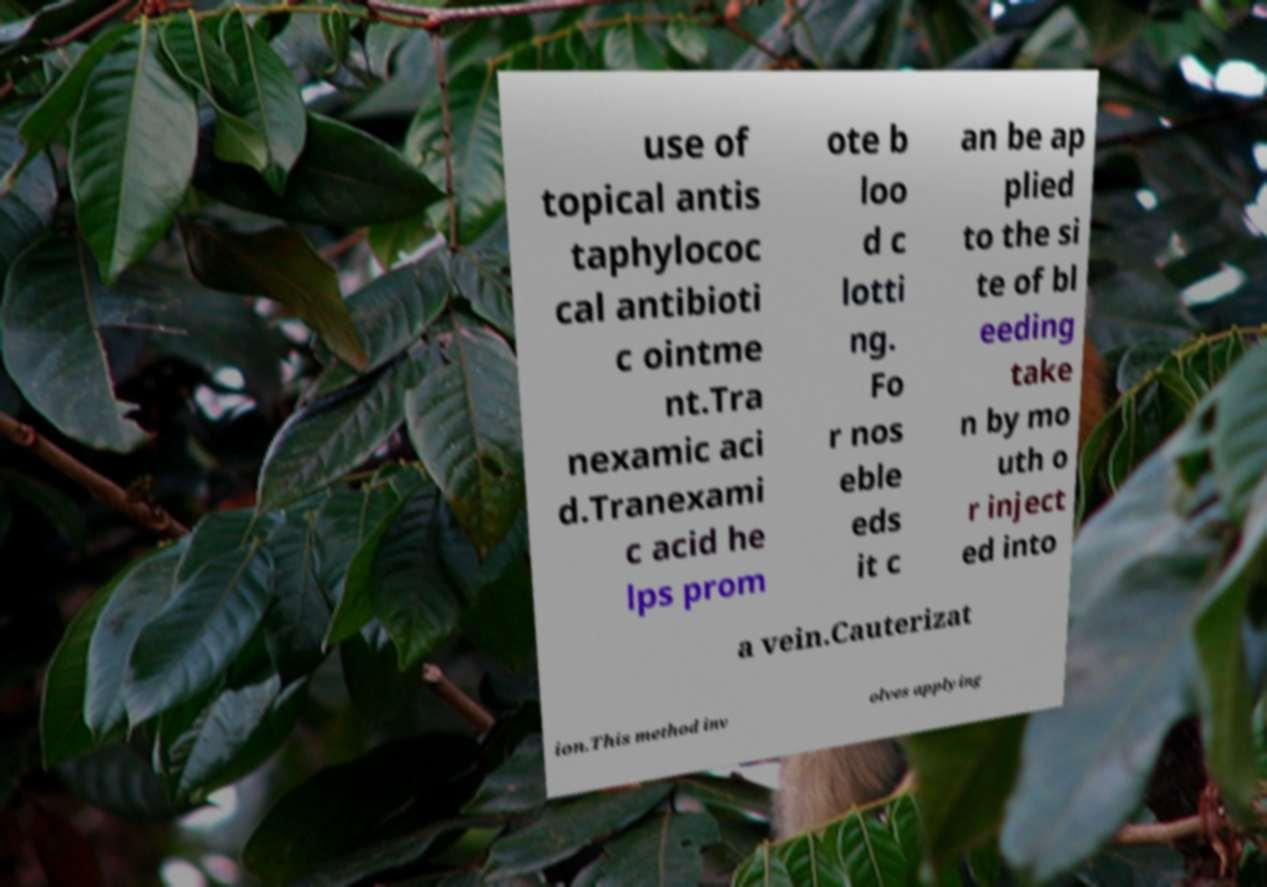For documentation purposes, I need the text within this image transcribed. Could you provide that? use of topical antis taphylococ cal antibioti c ointme nt.Tra nexamic aci d.Tranexami c acid he lps prom ote b loo d c lotti ng. Fo r nos eble eds it c an be ap plied to the si te of bl eeding take n by mo uth o r inject ed into a vein.Cauterizat ion.This method inv olves applying 